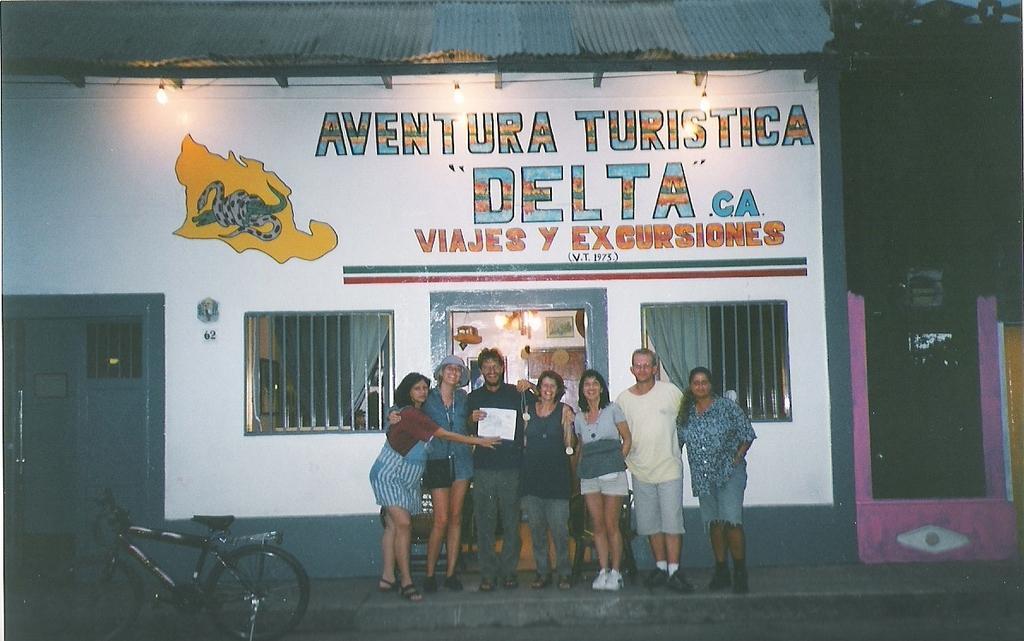Describe this image in one or two sentences. In the picture I can see a few women and men are standing and smiling. Here we can see a bicycle parked here. In the background, I can see a house on which I can see some text is painted, I can see the lamps, windows, curtains and the right side of the image is dark. 